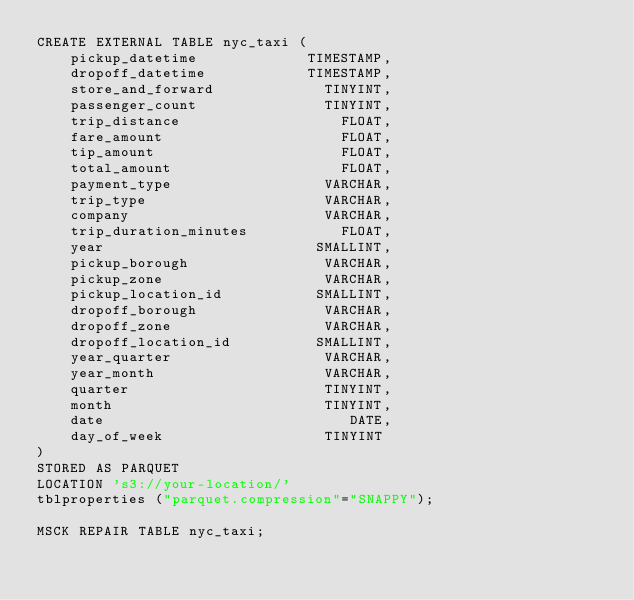<code> <loc_0><loc_0><loc_500><loc_500><_SQL_>CREATE EXTERNAL TABLE nyc_taxi (
    pickup_datetime             TIMESTAMP,
    dropoff_datetime            TIMESTAMP,
    store_and_forward             TINYINT,
    passenger_count               TINYINT,
    trip_distance                   FLOAT,
    fare_amount                     FLOAT,
    tip_amount                      FLOAT,
    total_amount                    FLOAT,
    payment_type                  VARCHAR,
    trip_type                     VARCHAR,
    company                       VARCHAR,
    trip_duration_minutes           FLOAT,
    year                         SMALLINT,
    pickup_borough                VARCHAR,
    pickup_zone                   VARCHAR,
    pickup_location_id           SMALLINT,
    dropoff_borough               VARCHAR,
    dropoff_zone                  VARCHAR,
    dropoff_location_id          SMALLINT,
    year_quarter                  VARCHAR,
    year_month                    VARCHAR,
    quarter                       TINYINT,
    month                         TINYINT,
    date                             DATE,
    day_of_week                   TINYINT
)
STORED AS PARQUET
LOCATION 's3://your-location/'
tblproperties ("parquet.compression"="SNAPPY");

MSCK REPAIR TABLE nyc_taxi;
</code> 